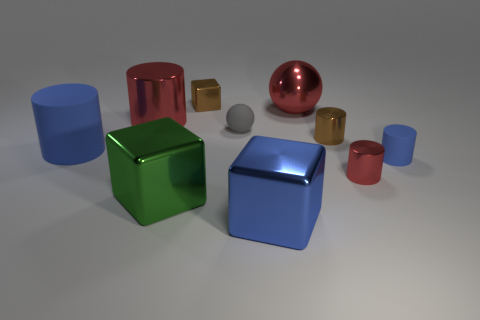What are the relative sizes of the objects? The red and blue cubes are the largest objects, followed by the green cube. The red and gold cylinders are medium-sized, while the silver sphere and the smallest cube, which is also red, are the smallest visible objects. 